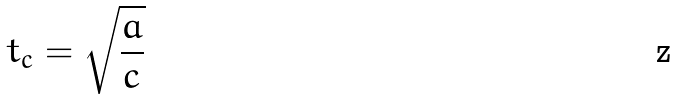Convert formula to latex. <formula><loc_0><loc_0><loc_500><loc_500>t _ { c } = \sqrt { \frac { a } { c } }</formula> 